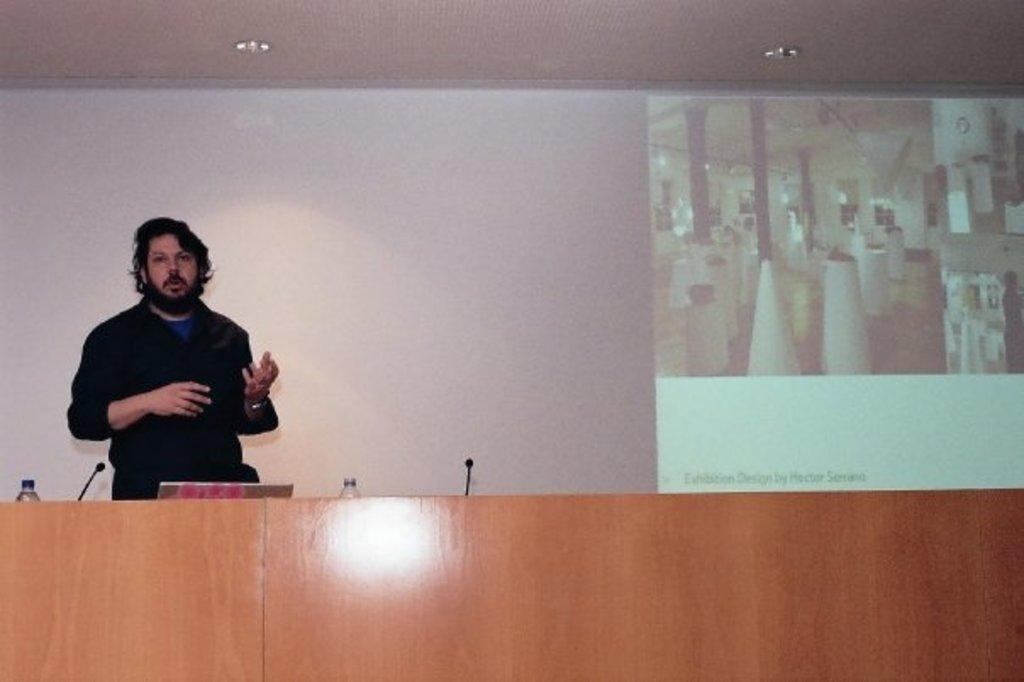What is the main subject in the image? There is a man standing in the image. What objects are present that might be related to the man's activity? There are microphones (mikes) in the image. What can be seen on the desks in the image? There are bottles on desks in the image. What type of lighting is present in the image? There are lights in the image. What can be seen in the background of the image? There is a screen in the background of the image. What type of crime is being committed in the image? There is no indication of a crime being committed in the image. Can you see any deer in the image? There are no deer present in the image. 